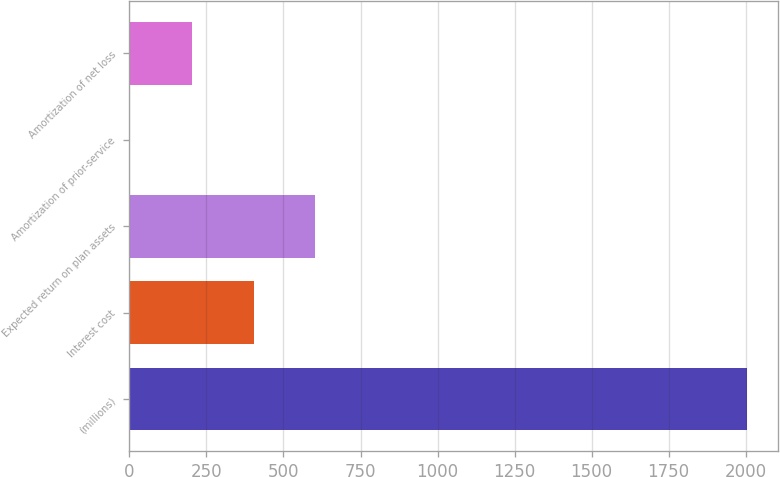<chart> <loc_0><loc_0><loc_500><loc_500><bar_chart><fcel>(millions)<fcel>Interest cost<fcel>Expected return on plan assets<fcel>Amortization of prior-service<fcel>Amortization of net loss<nl><fcel>2006<fcel>402.8<fcel>603.2<fcel>2<fcel>202.4<nl></chart> 